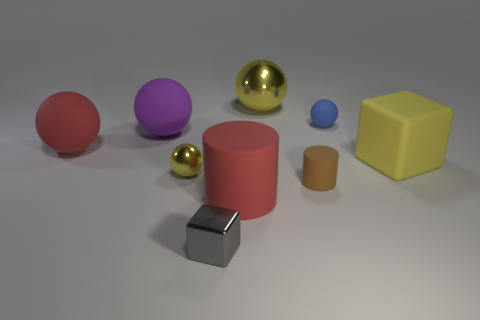Is the material of the large purple sphere the same as the ball behind the tiny blue matte ball?
Your answer should be very brief. No. There is a object that is on the right side of the small brown matte thing and behind the purple sphere; what is it made of?
Offer a very short reply. Rubber. What is the color of the rubber ball that is on the right side of the big red object on the right side of the tiny gray metal cube?
Ensure brevity in your answer.  Blue. There is a big yellow object on the left side of the big yellow block; what is it made of?
Offer a very short reply. Metal. Is the number of purple matte spheres less than the number of tiny blue metallic blocks?
Offer a terse response. No. There is a large yellow matte thing; is its shape the same as the big matte object that is behind the red matte sphere?
Your answer should be very brief. No. The tiny thing that is both behind the small gray shiny object and to the left of the brown rubber thing has what shape?
Provide a succinct answer. Sphere. Are there the same number of yellow rubber blocks behind the yellow matte cube and brown rubber cylinders that are on the left side of the large red matte cylinder?
Provide a succinct answer. Yes. Does the red matte object in front of the tiny brown cylinder have the same shape as the big purple thing?
Your answer should be compact. No. How many yellow objects are small shiny blocks or tiny balls?
Your response must be concise. 1. 